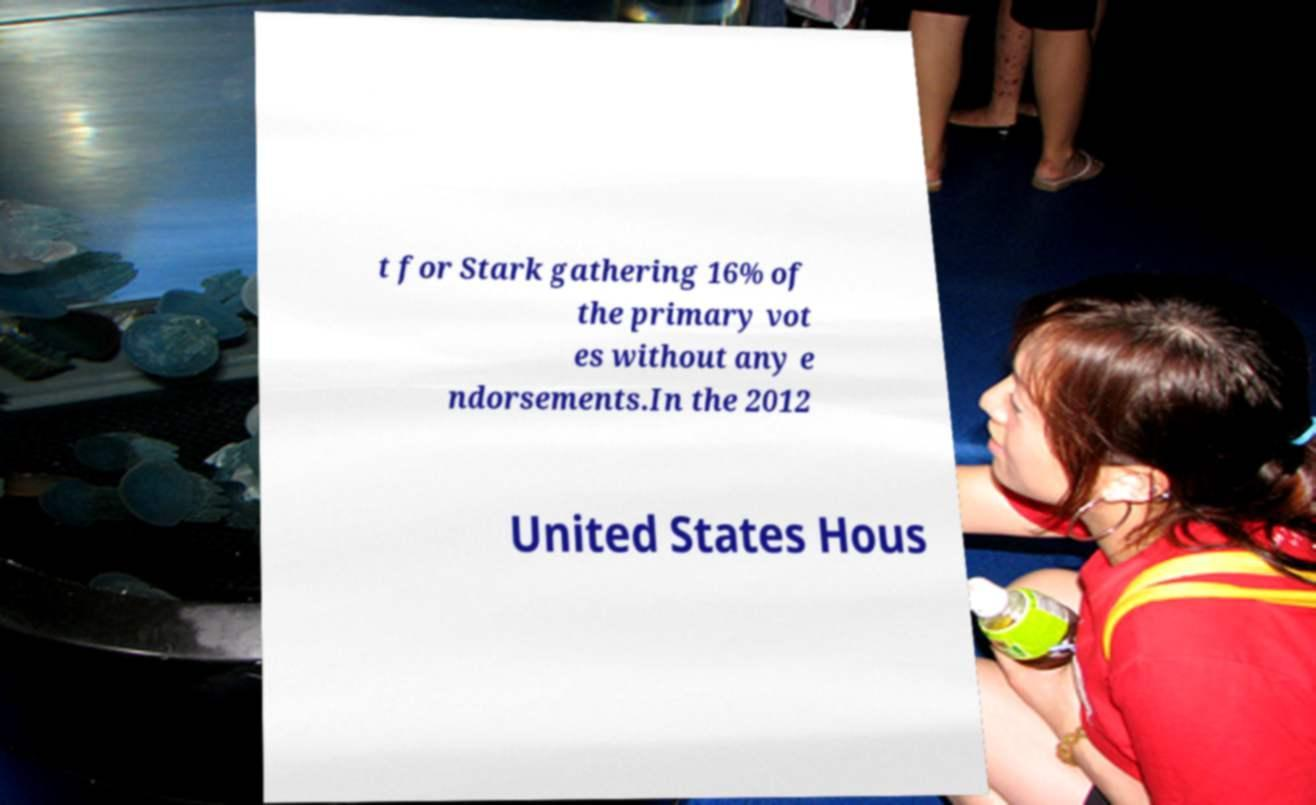Could you extract and type out the text from this image? t for Stark gathering 16% of the primary vot es without any e ndorsements.In the 2012 United States Hous 